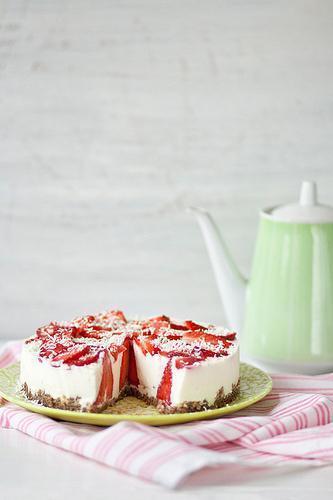How many plates are on the table?
Give a very brief answer. 1. How many napkins seen on the table?
Give a very brief answer. 1. 